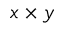Convert formula to latex. <formula><loc_0><loc_0><loc_500><loc_500>x \times y</formula> 